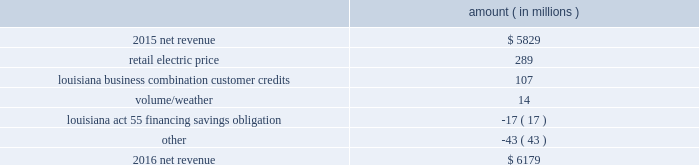( $ 66 million net-of-tax ) as a result of customer credits to be realized by electric customers of entergy louisiana , consistent with the terms of the stipulated settlement in the business combination proceeding .
See note 2 to the financial statements for further discussion of the business combination and customer credits .
Results of operations for 2015 also include the sale in december 2015 of the 583 mw rhode island state energy center for a realized gain of $ 154 million ( $ 100 million net-of-tax ) on the sale and the $ 77 million ( $ 47 million net-of-tax ) write-off and regulatory charges to recognize that a portion of the assets associated with the waterford 3 replacement steam generator project is no longer probable of recovery .
See note 14 to the financial statements for further discussion of the rhode island state energy center sale .
See note 2 to the financial statements for further discussion of the waterford 3 replacement steam generator prudence review proceeding .
Net revenue utility following is an analysis of the change in net revenue comparing 2016 to 2015 .
Amount ( in millions ) .
The retail electric price variance is primarily due to : 2022 an increase in base rates at entergy arkansas , as approved by the apsc .
The new rates were effective february 24 , 2016 and began billing with the first billing cycle of april 2016 .
The increase included an interim base rate adjustment surcharge , effective with the first billing cycle of april 2016 , to recover the incremental revenue requirement for the period february 24 , 2016 through march 31 , 2016 .
A significant portion of the increase was related to the purchase of power block 2 of the union power station ; 2022 an increase in the purchased power and capacity acquisition cost recovery rider for entergy new orleans , as approved by the city council , effective with the first billing cycle of march 2016 , primarily related to the purchase of power block 1 of the union power station ; 2022 an increase in formula rate plan revenues for entergy louisiana , implemented with the first billing cycle of march 2016 , to collect the estimated first-year revenue requirement related to the purchase of power blocks 3 and 4 of the union power station ; and 2022 an increase in revenues at entergy mississippi , as approved by the mpsc , effective with the first billing cycle of july 2016 , and an increase in revenues collected through the storm damage rider .
See note 2 to the financial statements for further discussion of the rate proceedings .
See note 14 to the financial statements for discussion of the union power station purchase .
The louisiana business combination customer credits variance is due to a regulatory liability of $ 107 million recorded by entergy in october 2015 as a result of the entergy gulf states louisiana and entergy louisiana business combination .
Consistent with the terms of the stipulated settlement in the business combination proceeding , electric customers of entergy louisiana will realize customer credits associated with the business combination ; accordingly , in october 2015 , entergy recorded a regulatory liability of $ 107 million ( $ 66 million net-of-tax ) .
These costs are being entergy corporation and subsidiaries management 2019s financial discussion and analysis .
What portion of the net change in net revenue during 2016 is related to the change in retail electric price? 
Computations: (289 / (6179 - 5829))
Answer: 0.82571. 